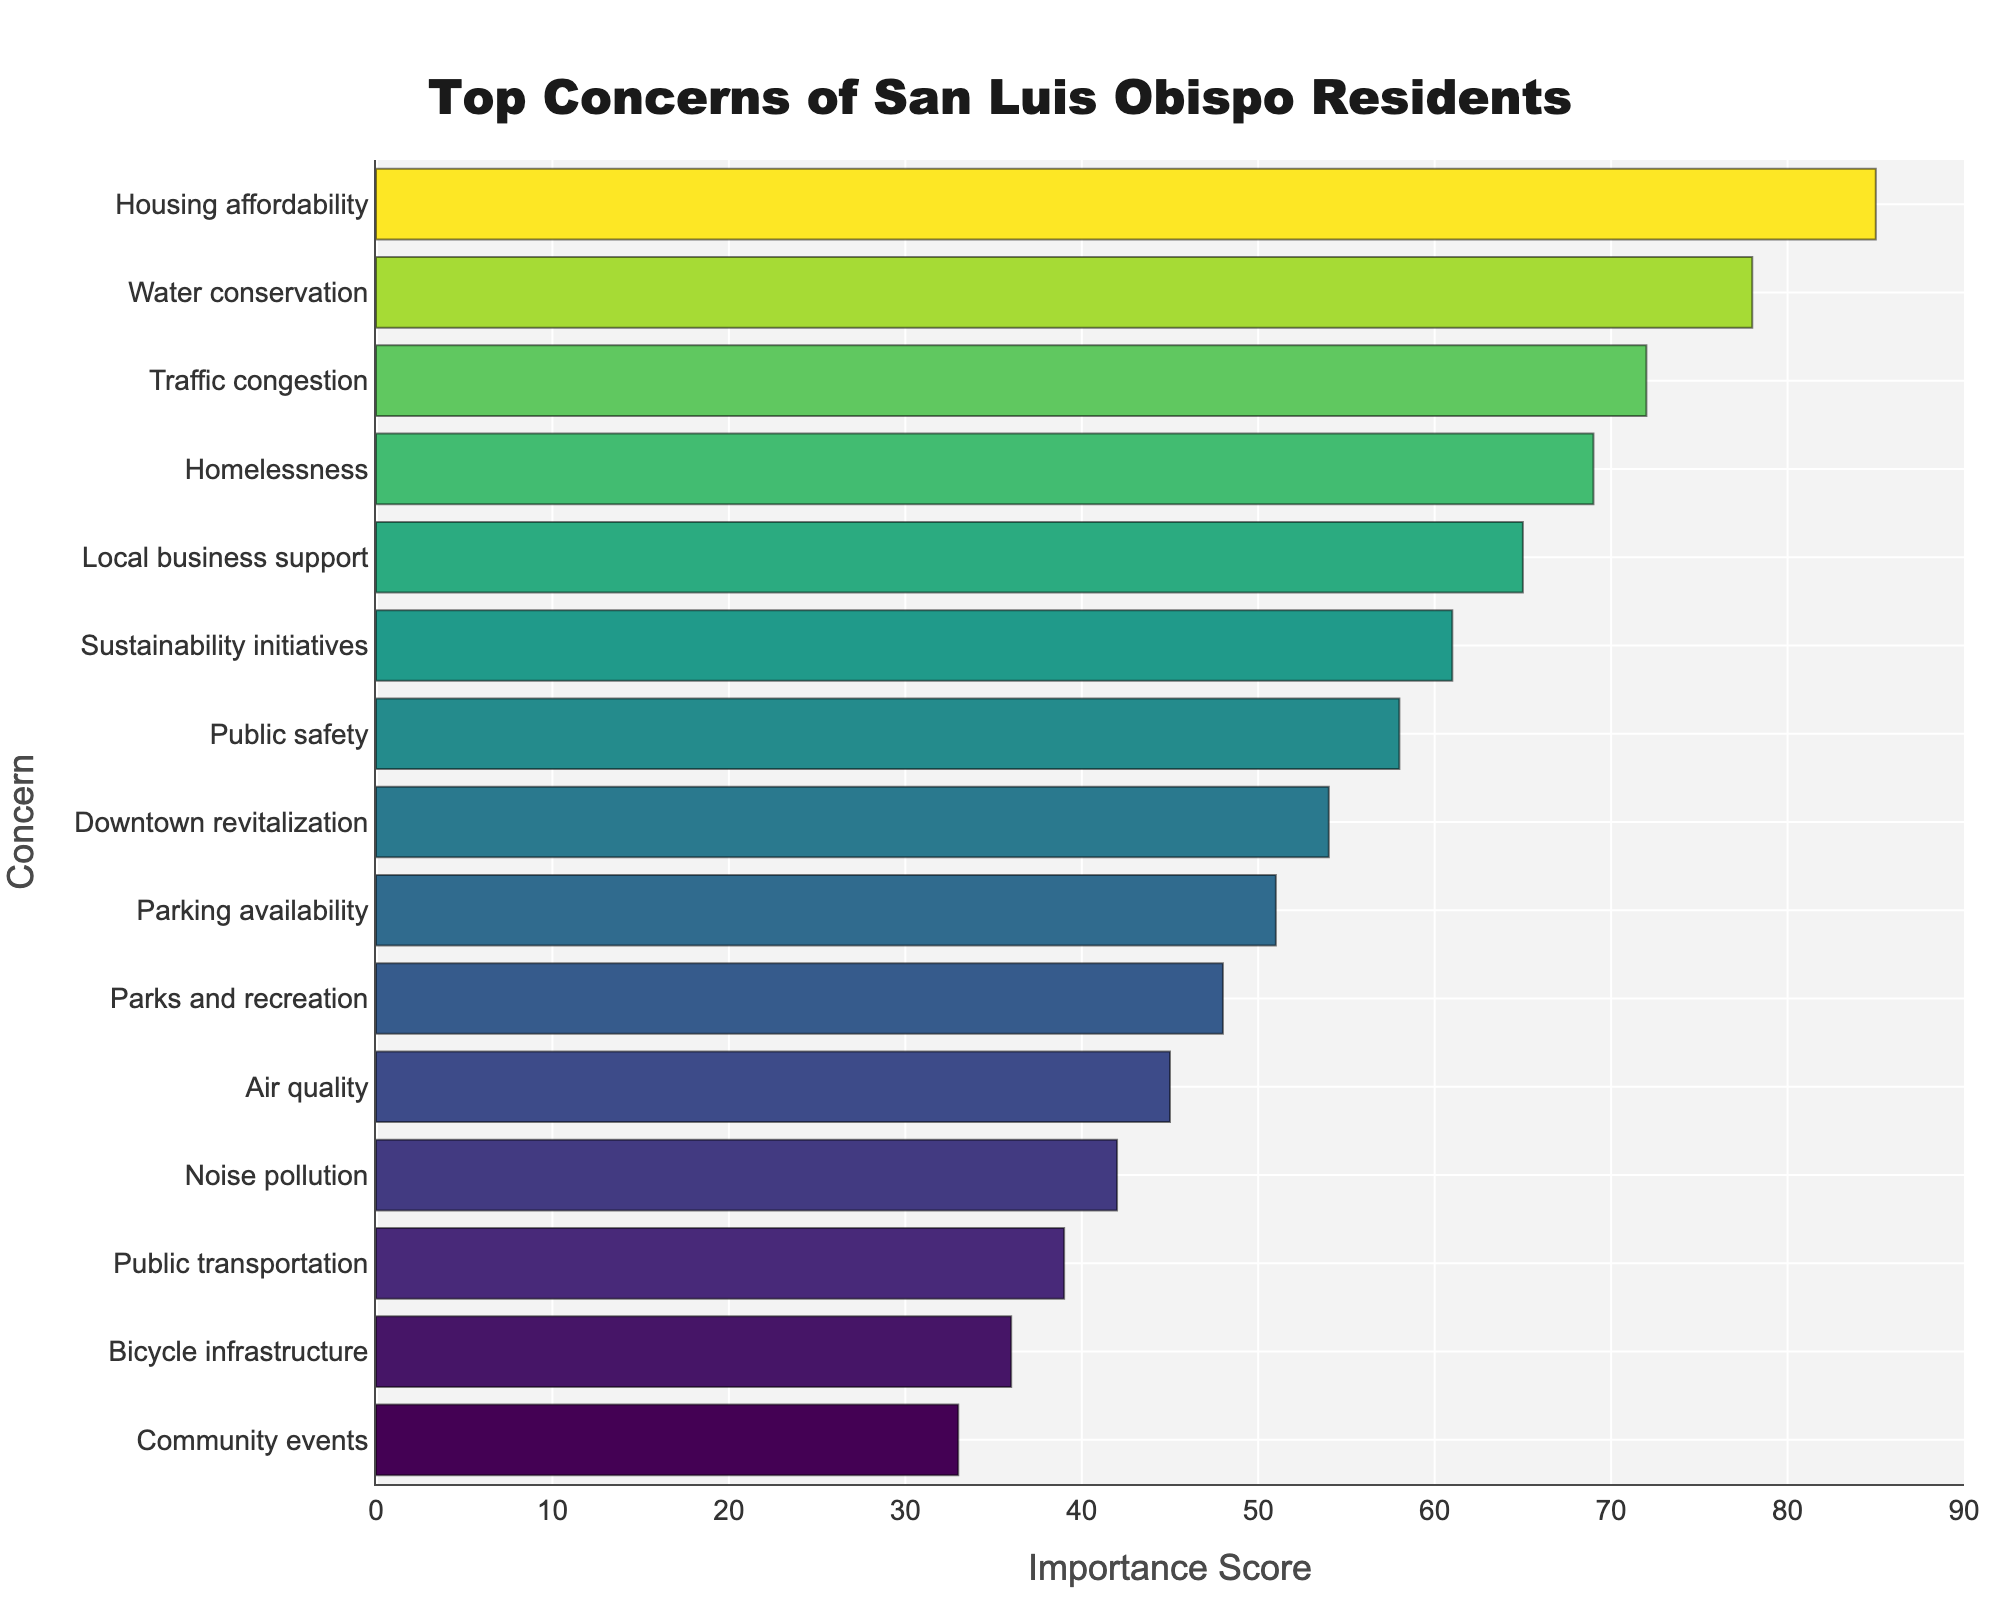Which concern has the highest importance score? The highest bar represents the concern with the highest importance score. This concern is "Housing affordability" with an importance score of 85.
Answer: Housing affordability Which two concerns have the closest importance scores? By visually inspecting the bars, "Downtown revitalization" and "Parking availability" appear to have the closest importance scores of 54 and 51, respectively.
Answer: Downtown revitalization and Parking availability What is the difference in importance score between the highest and lowest ranked concerns? The highest importance score is 85 (Housing affordability) and the lowest is 33 (Community events). The difference is calculated as 85 - 33 = 52.
Answer: 52 Which concerns have an importance score greater than 70? By examining the length of the bars, the concerns with scores greater than 70 are "Housing affordability" (85), "Water conservation" (78), and "Traffic congestion" (72).
Answer: Three concerns: Housing affordability, Water conservation, and Traffic congestion How many concerns have an importance score less than 50? The bars representing concerns with scores less than 50 include "Parks and recreation" (48), "Air quality" (45), "Noise pollution" (42), "Public transportation" (39), "Bicycle infrastructure" (36), and "Community events" (33). There are 6 concerns in total.
Answer: 6 What is the combined importance score of "Traffic congestion" and "Homelessness"? "Traffic congestion" has a score of 72 and "Homelessness" has a score of 69. Summing these values: 72 + 69 = 141.
Answer: 141 Which concern has the second lowest importance score? The second shortest bar represents the concern with the second lowest importance score, which is "Bicycle infrastructure" with a score of 36.
Answer: Bicycle infrastructure Of the top 5 concerns by importance score, how many are related to infrastructure? The top 5 concerns are "Housing affordability", "Water conservation", "Traffic congestion", "Homelessness", and "Local business support". Only "Traffic congestion" can be classified as related to infrastructure.
Answer: 1 What is the average importance score of "Public transportation", "Bicycle infrastructure", and "Community events"? The importance scores are 39, 36, and 33 respectively. The sum is 39 + 36 + 33 = 108. The average is 108 / 3 = 36.
Answer: 36 Which concern out of "Local business support" and "Sustainability initiatives" has a higher importance score, and by how much? "Local business support" has a score of 65 and "Sustainability initiatives" has a score of 61. "Local business support" is higher by 65 - 61 = 4 points.
Answer: Local business support by 4 points 